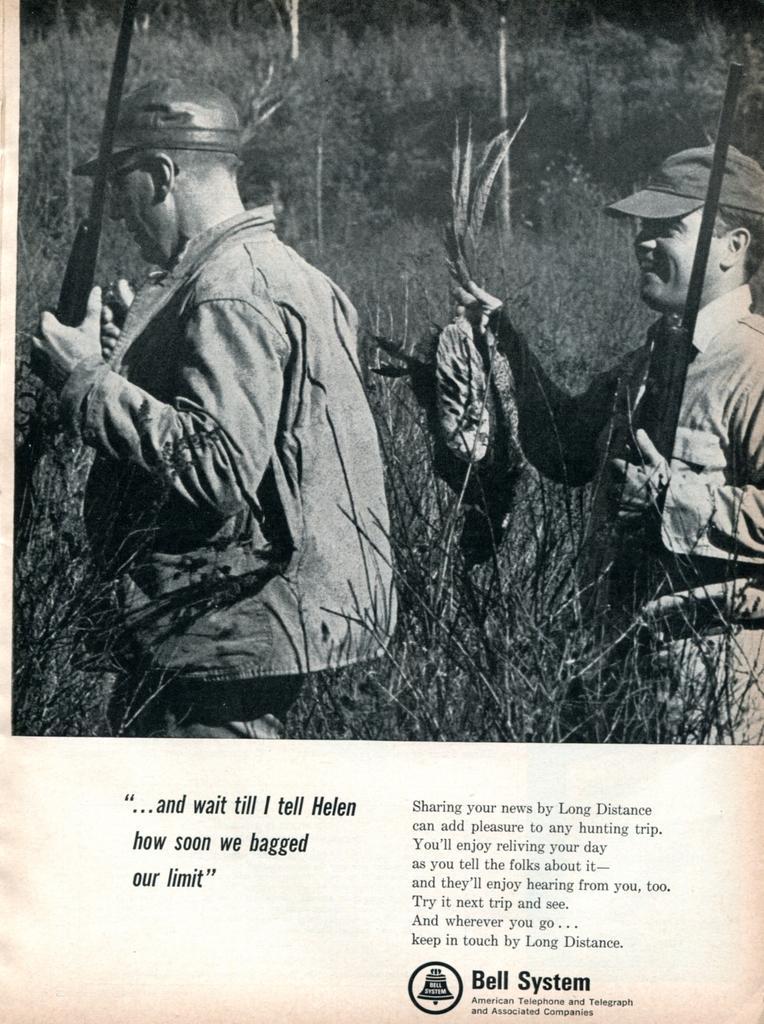How would you summarize this image in a sentence or two? In this image we can see two men. One is one the left side and the other one is on the right side. They are holding weapons in their hands. Here we can see the man on the right side holding an animal in his right hand. In the background, we can see the trees. 